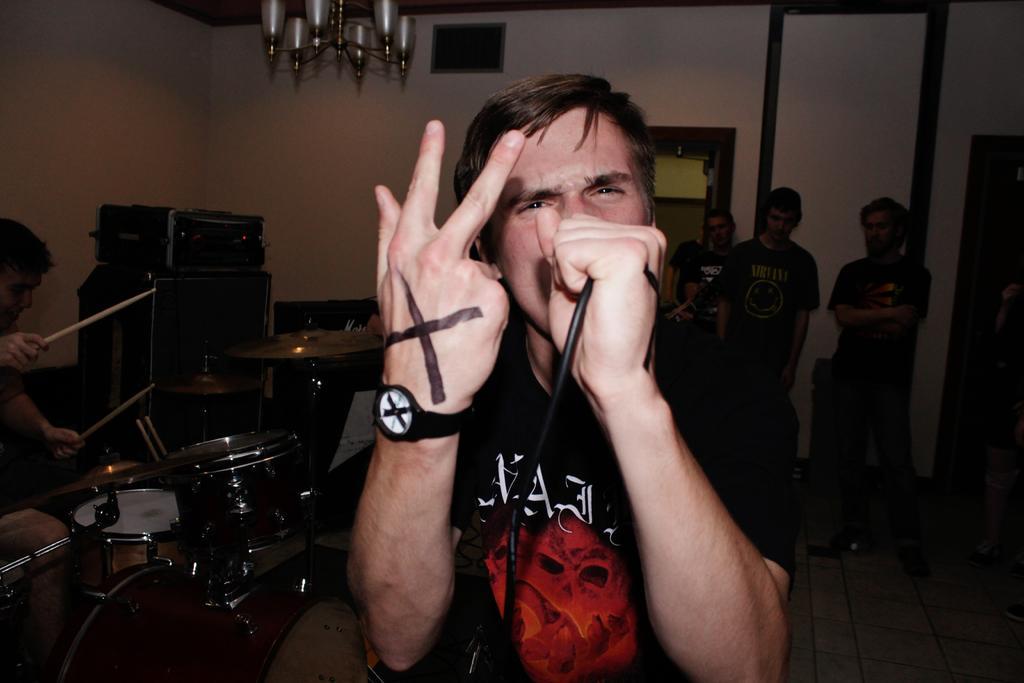Please provide a concise description of this image. A man is standing the microphone in his hands and on the left a man is beating the drums. Right few people are standing. 